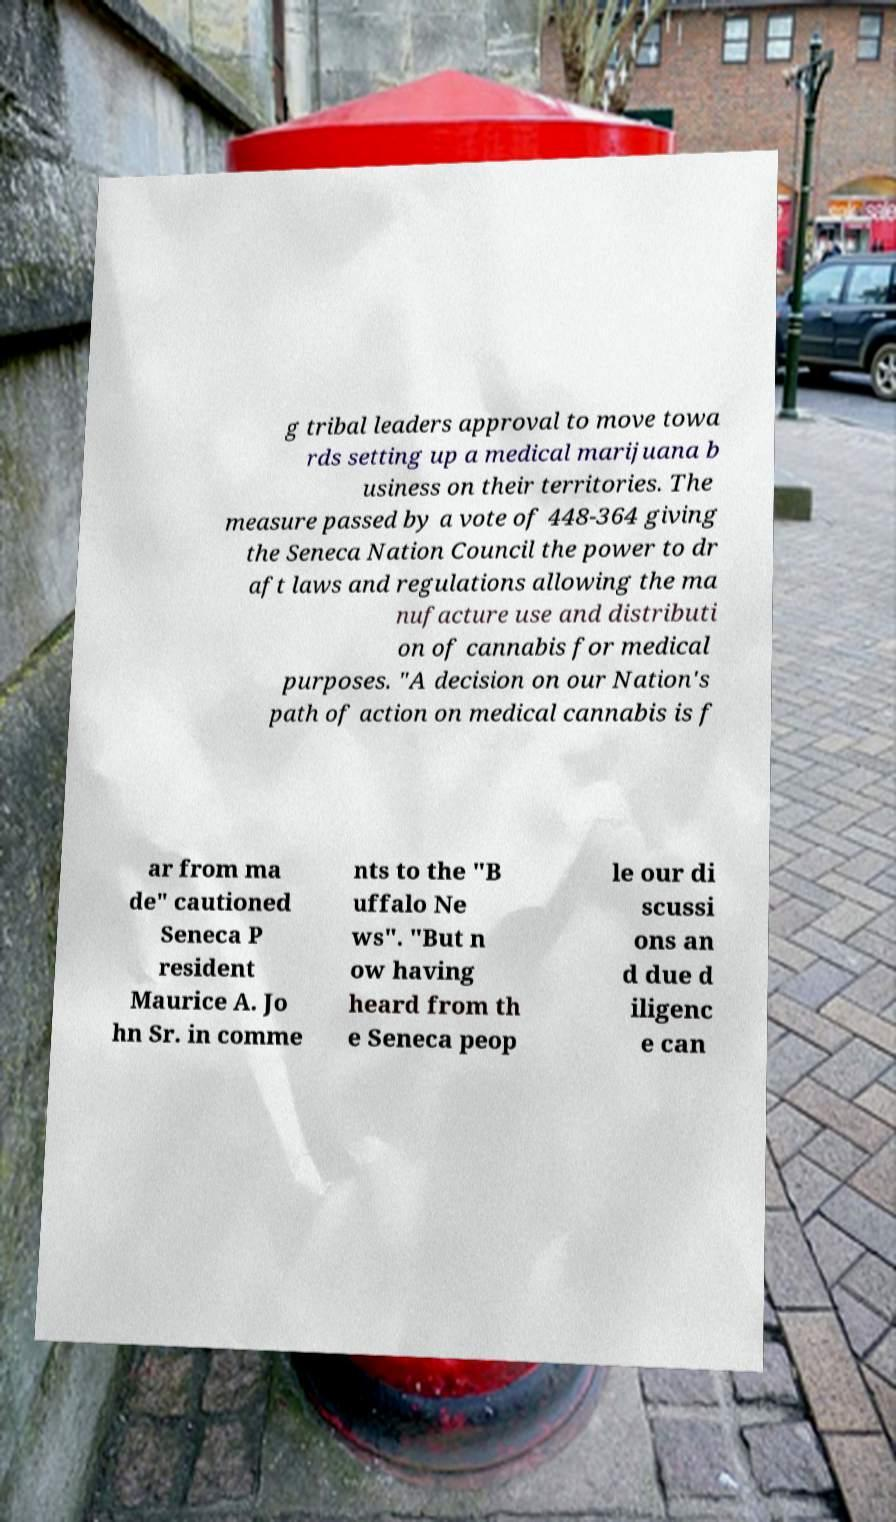What messages or text are displayed in this image? I need them in a readable, typed format. g tribal leaders approval to move towa rds setting up a medical marijuana b usiness on their territories. The measure passed by a vote of 448-364 giving the Seneca Nation Council the power to dr aft laws and regulations allowing the ma nufacture use and distributi on of cannabis for medical purposes. "A decision on our Nation's path of action on medical cannabis is f ar from ma de" cautioned Seneca P resident Maurice A. Jo hn Sr. in comme nts to the "B uffalo Ne ws". "But n ow having heard from th e Seneca peop le our di scussi ons an d due d iligenc e can 